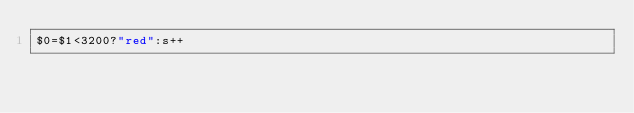Convert code to text. <code><loc_0><loc_0><loc_500><loc_500><_Awk_>$0=$1<3200?"red":s++</code> 